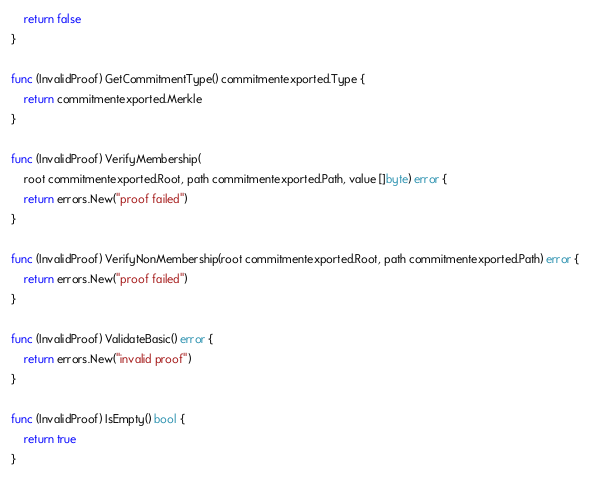Convert code to text. <code><loc_0><loc_0><loc_500><loc_500><_Go_>	return false
}

func (InvalidProof) GetCommitmentType() commitmentexported.Type {
	return commitmentexported.Merkle
}

func (InvalidProof) VerifyMembership(
	root commitmentexported.Root, path commitmentexported.Path, value []byte) error {
	return errors.New("proof failed")
}

func (InvalidProof) VerifyNonMembership(root commitmentexported.Root, path commitmentexported.Path) error {
	return errors.New("proof failed")
}

func (InvalidProof) ValidateBasic() error {
	return errors.New("invalid proof")
}

func (InvalidProof) IsEmpty() bool {
	return true
}
</code> 